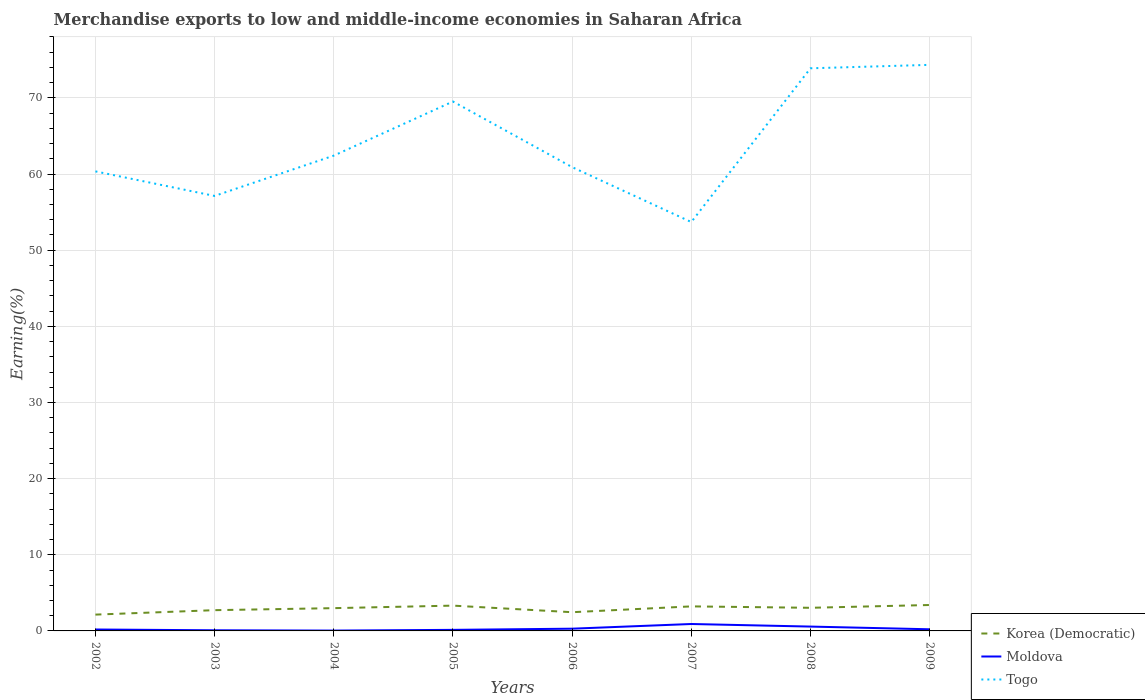Across all years, what is the maximum percentage of amount earned from merchandise exports in Moldova?
Keep it short and to the point. 0.05. In which year was the percentage of amount earned from merchandise exports in Moldova maximum?
Your response must be concise. 2004. What is the total percentage of amount earned from merchandise exports in Togo in the graph?
Offer a very short reply. -5.29. What is the difference between the highest and the second highest percentage of amount earned from merchandise exports in Togo?
Ensure brevity in your answer.  20.64. Is the percentage of amount earned from merchandise exports in Korea (Democratic) strictly greater than the percentage of amount earned from merchandise exports in Moldova over the years?
Provide a succinct answer. No. What is the difference between two consecutive major ticks on the Y-axis?
Make the answer very short. 10. Does the graph contain any zero values?
Keep it short and to the point. No. Does the graph contain grids?
Give a very brief answer. Yes. How many legend labels are there?
Your response must be concise. 3. How are the legend labels stacked?
Offer a very short reply. Vertical. What is the title of the graph?
Give a very brief answer. Merchandise exports to low and middle-income economies in Saharan Africa. Does "Benin" appear as one of the legend labels in the graph?
Make the answer very short. No. What is the label or title of the X-axis?
Provide a succinct answer. Years. What is the label or title of the Y-axis?
Offer a terse response. Earning(%). What is the Earning(%) of Korea (Democratic) in 2002?
Your answer should be compact. 2.14. What is the Earning(%) in Moldova in 2002?
Your answer should be compact. 0.19. What is the Earning(%) in Togo in 2002?
Offer a terse response. 60.35. What is the Earning(%) of Korea (Democratic) in 2003?
Offer a terse response. 2.73. What is the Earning(%) of Moldova in 2003?
Keep it short and to the point. 0.08. What is the Earning(%) of Togo in 2003?
Ensure brevity in your answer.  57.13. What is the Earning(%) in Korea (Democratic) in 2004?
Your answer should be very brief. 2.99. What is the Earning(%) of Moldova in 2004?
Give a very brief answer. 0.05. What is the Earning(%) in Togo in 2004?
Offer a very short reply. 62.42. What is the Earning(%) of Korea (Democratic) in 2005?
Give a very brief answer. 3.32. What is the Earning(%) in Moldova in 2005?
Make the answer very short. 0.14. What is the Earning(%) of Togo in 2005?
Give a very brief answer. 69.53. What is the Earning(%) in Korea (Democratic) in 2006?
Your answer should be very brief. 2.46. What is the Earning(%) of Moldova in 2006?
Give a very brief answer. 0.29. What is the Earning(%) in Togo in 2006?
Keep it short and to the point. 60.91. What is the Earning(%) of Korea (Democratic) in 2007?
Your response must be concise. 3.22. What is the Earning(%) in Moldova in 2007?
Your response must be concise. 0.91. What is the Earning(%) in Togo in 2007?
Your answer should be very brief. 53.7. What is the Earning(%) in Korea (Democratic) in 2008?
Provide a short and direct response. 3.04. What is the Earning(%) of Moldova in 2008?
Offer a terse response. 0.57. What is the Earning(%) of Togo in 2008?
Your answer should be compact. 73.89. What is the Earning(%) of Korea (Democratic) in 2009?
Offer a very short reply. 3.4. What is the Earning(%) of Moldova in 2009?
Offer a very short reply. 0.21. What is the Earning(%) of Togo in 2009?
Your answer should be compact. 74.34. Across all years, what is the maximum Earning(%) of Korea (Democratic)?
Your answer should be compact. 3.4. Across all years, what is the maximum Earning(%) in Moldova?
Provide a short and direct response. 0.91. Across all years, what is the maximum Earning(%) of Togo?
Offer a very short reply. 74.34. Across all years, what is the minimum Earning(%) of Korea (Democratic)?
Keep it short and to the point. 2.14. Across all years, what is the minimum Earning(%) of Moldova?
Give a very brief answer. 0.05. Across all years, what is the minimum Earning(%) of Togo?
Ensure brevity in your answer.  53.7. What is the total Earning(%) in Korea (Democratic) in the graph?
Your response must be concise. 23.3. What is the total Earning(%) of Moldova in the graph?
Provide a succinct answer. 2.44. What is the total Earning(%) in Togo in the graph?
Make the answer very short. 512.25. What is the difference between the Earning(%) of Korea (Democratic) in 2002 and that in 2003?
Make the answer very short. -0.58. What is the difference between the Earning(%) of Moldova in 2002 and that in 2003?
Ensure brevity in your answer.  0.1. What is the difference between the Earning(%) in Togo in 2002 and that in 2003?
Provide a succinct answer. 3.22. What is the difference between the Earning(%) of Korea (Democratic) in 2002 and that in 2004?
Keep it short and to the point. -0.85. What is the difference between the Earning(%) in Moldova in 2002 and that in 2004?
Your answer should be very brief. 0.14. What is the difference between the Earning(%) in Togo in 2002 and that in 2004?
Keep it short and to the point. -2.07. What is the difference between the Earning(%) in Korea (Democratic) in 2002 and that in 2005?
Your answer should be compact. -1.18. What is the difference between the Earning(%) of Moldova in 2002 and that in 2005?
Give a very brief answer. 0.05. What is the difference between the Earning(%) in Togo in 2002 and that in 2005?
Your response must be concise. -9.17. What is the difference between the Earning(%) in Korea (Democratic) in 2002 and that in 2006?
Your answer should be compact. -0.32. What is the difference between the Earning(%) of Moldova in 2002 and that in 2006?
Your answer should be very brief. -0.11. What is the difference between the Earning(%) of Togo in 2002 and that in 2006?
Ensure brevity in your answer.  -0.56. What is the difference between the Earning(%) of Korea (Democratic) in 2002 and that in 2007?
Keep it short and to the point. -1.08. What is the difference between the Earning(%) of Moldova in 2002 and that in 2007?
Offer a very short reply. -0.72. What is the difference between the Earning(%) in Togo in 2002 and that in 2007?
Your response must be concise. 6.65. What is the difference between the Earning(%) of Korea (Democratic) in 2002 and that in 2008?
Your response must be concise. -0.89. What is the difference between the Earning(%) in Moldova in 2002 and that in 2008?
Offer a terse response. -0.38. What is the difference between the Earning(%) in Togo in 2002 and that in 2008?
Provide a short and direct response. -13.54. What is the difference between the Earning(%) in Korea (Democratic) in 2002 and that in 2009?
Offer a very short reply. -1.26. What is the difference between the Earning(%) in Moldova in 2002 and that in 2009?
Provide a short and direct response. -0.03. What is the difference between the Earning(%) of Togo in 2002 and that in 2009?
Your answer should be compact. -13.99. What is the difference between the Earning(%) of Korea (Democratic) in 2003 and that in 2004?
Offer a very short reply. -0.27. What is the difference between the Earning(%) of Moldova in 2003 and that in 2004?
Offer a terse response. 0.04. What is the difference between the Earning(%) of Togo in 2003 and that in 2004?
Give a very brief answer. -5.29. What is the difference between the Earning(%) in Korea (Democratic) in 2003 and that in 2005?
Provide a short and direct response. -0.6. What is the difference between the Earning(%) in Moldova in 2003 and that in 2005?
Provide a succinct answer. -0.05. What is the difference between the Earning(%) of Togo in 2003 and that in 2005?
Give a very brief answer. -12.4. What is the difference between the Earning(%) of Korea (Democratic) in 2003 and that in 2006?
Keep it short and to the point. 0.27. What is the difference between the Earning(%) of Moldova in 2003 and that in 2006?
Provide a succinct answer. -0.21. What is the difference between the Earning(%) in Togo in 2003 and that in 2006?
Provide a short and direct response. -3.78. What is the difference between the Earning(%) in Korea (Democratic) in 2003 and that in 2007?
Provide a short and direct response. -0.5. What is the difference between the Earning(%) in Moldova in 2003 and that in 2007?
Make the answer very short. -0.82. What is the difference between the Earning(%) of Togo in 2003 and that in 2007?
Your response must be concise. 3.43. What is the difference between the Earning(%) of Korea (Democratic) in 2003 and that in 2008?
Offer a terse response. -0.31. What is the difference between the Earning(%) in Moldova in 2003 and that in 2008?
Provide a short and direct response. -0.49. What is the difference between the Earning(%) of Togo in 2003 and that in 2008?
Provide a short and direct response. -16.76. What is the difference between the Earning(%) in Korea (Democratic) in 2003 and that in 2009?
Your response must be concise. -0.68. What is the difference between the Earning(%) of Moldova in 2003 and that in 2009?
Make the answer very short. -0.13. What is the difference between the Earning(%) of Togo in 2003 and that in 2009?
Your response must be concise. -17.21. What is the difference between the Earning(%) in Korea (Democratic) in 2004 and that in 2005?
Offer a very short reply. -0.33. What is the difference between the Earning(%) in Moldova in 2004 and that in 2005?
Your answer should be very brief. -0.09. What is the difference between the Earning(%) in Togo in 2004 and that in 2005?
Keep it short and to the point. -7.11. What is the difference between the Earning(%) in Korea (Democratic) in 2004 and that in 2006?
Your answer should be compact. 0.53. What is the difference between the Earning(%) in Moldova in 2004 and that in 2006?
Offer a terse response. -0.25. What is the difference between the Earning(%) of Togo in 2004 and that in 2006?
Offer a very short reply. 1.51. What is the difference between the Earning(%) in Korea (Democratic) in 2004 and that in 2007?
Keep it short and to the point. -0.23. What is the difference between the Earning(%) of Moldova in 2004 and that in 2007?
Make the answer very short. -0.86. What is the difference between the Earning(%) in Togo in 2004 and that in 2007?
Offer a terse response. 8.72. What is the difference between the Earning(%) in Korea (Democratic) in 2004 and that in 2008?
Offer a very short reply. -0.05. What is the difference between the Earning(%) of Moldova in 2004 and that in 2008?
Your response must be concise. -0.52. What is the difference between the Earning(%) of Togo in 2004 and that in 2008?
Offer a very short reply. -11.47. What is the difference between the Earning(%) in Korea (Democratic) in 2004 and that in 2009?
Offer a very short reply. -0.41. What is the difference between the Earning(%) of Moldova in 2004 and that in 2009?
Keep it short and to the point. -0.17. What is the difference between the Earning(%) of Togo in 2004 and that in 2009?
Your answer should be compact. -11.92. What is the difference between the Earning(%) of Korea (Democratic) in 2005 and that in 2006?
Provide a short and direct response. 0.86. What is the difference between the Earning(%) of Moldova in 2005 and that in 2006?
Keep it short and to the point. -0.15. What is the difference between the Earning(%) in Togo in 2005 and that in 2006?
Give a very brief answer. 8.62. What is the difference between the Earning(%) in Korea (Democratic) in 2005 and that in 2007?
Offer a very short reply. 0.1. What is the difference between the Earning(%) of Moldova in 2005 and that in 2007?
Offer a very short reply. -0.77. What is the difference between the Earning(%) in Togo in 2005 and that in 2007?
Provide a succinct answer. 15.83. What is the difference between the Earning(%) of Korea (Democratic) in 2005 and that in 2008?
Offer a terse response. 0.28. What is the difference between the Earning(%) in Moldova in 2005 and that in 2008?
Your answer should be compact. -0.43. What is the difference between the Earning(%) of Togo in 2005 and that in 2008?
Your answer should be compact. -4.36. What is the difference between the Earning(%) of Korea (Democratic) in 2005 and that in 2009?
Offer a very short reply. -0.08. What is the difference between the Earning(%) of Moldova in 2005 and that in 2009?
Your response must be concise. -0.08. What is the difference between the Earning(%) of Togo in 2005 and that in 2009?
Give a very brief answer. -4.81. What is the difference between the Earning(%) of Korea (Democratic) in 2006 and that in 2007?
Your answer should be very brief. -0.76. What is the difference between the Earning(%) in Moldova in 2006 and that in 2007?
Provide a succinct answer. -0.62. What is the difference between the Earning(%) in Togo in 2006 and that in 2007?
Offer a terse response. 7.21. What is the difference between the Earning(%) of Korea (Democratic) in 2006 and that in 2008?
Your response must be concise. -0.58. What is the difference between the Earning(%) of Moldova in 2006 and that in 2008?
Your answer should be very brief. -0.28. What is the difference between the Earning(%) in Togo in 2006 and that in 2008?
Your answer should be compact. -12.98. What is the difference between the Earning(%) in Korea (Democratic) in 2006 and that in 2009?
Ensure brevity in your answer.  -0.95. What is the difference between the Earning(%) of Moldova in 2006 and that in 2009?
Ensure brevity in your answer.  0.08. What is the difference between the Earning(%) in Togo in 2006 and that in 2009?
Ensure brevity in your answer.  -13.43. What is the difference between the Earning(%) of Korea (Democratic) in 2007 and that in 2008?
Make the answer very short. 0.19. What is the difference between the Earning(%) of Moldova in 2007 and that in 2008?
Your answer should be compact. 0.34. What is the difference between the Earning(%) in Togo in 2007 and that in 2008?
Provide a succinct answer. -20.19. What is the difference between the Earning(%) of Korea (Democratic) in 2007 and that in 2009?
Give a very brief answer. -0.18. What is the difference between the Earning(%) of Moldova in 2007 and that in 2009?
Your response must be concise. 0.69. What is the difference between the Earning(%) in Togo in 2007 and that in 2009?
Your response must be concise. -20.64. What is the difference between the Earning(%) of Korea (Democratic) in 2008 and that in 2009?
Make the answer very short. -0.37. What is the difference between the Earning(%) in Moldova in 2008 and that in 2009?
Offer a very short reply. 0.36. What is the difference between the Earning(%) of Togo in 2008 and that in 2009?
Ensure brevity in your answer.  -0.45. What is the difference between the Earning(%) of Korea (Democratic) in 2002 and the Earning(%) of Moldova in 2003?
Ensure brevity in your answer.  2.06. What is the difference between the Earning(%) in Korea (Democratic) in 2002 and the Earning(%) in Togo in 2003?
Your response must be concise. -54.98. What is the difference between the Earning(%) in Moldova in 2002 and the Earning(%) in Togo in 2003?
Offer a very short reply. -56.94. What is the difference between the Earning(%) of Korea (Democratic) in 2002 and the Earning(%) of Moldova in 2004?
Make the answer very short. 2.1. What is the difference between the Earning(%) of Korea (Democratic) in 2002 and the Earning(%) of Togo in 2004?
Provide a short and direct response. -60.28. What is the difference between the Earning(%) in Moldova in 2002 and the Earning(%) in Togo in 2004?
Ensure brevity in your answer.  -62.23. What is the difference between the Earning(%) of Korea (Democratic) in 2002 and the Earning(%) of Moldova in 2005?
Your answer should be compact. 2. What is the difference between the Earning(%) of Korea (Democratic) in 2002 and the Earning(%) of Togo in 2005?
Provide a short and direct response. -67.38. What is the difference between the Earning(%) of Moldova in 2002 and the Earning(%) of Togo in 2005?
Offer a terse response. -69.34. What is the difference between the Earning(%) of Korea (Democratic) in 2002 and the Earning(%) of Moldova in 2006?
Your answer should be very brief. 1.85. What is the difference between the Earning(%) of Korea (Democratic) in 2002 and the Earning(%) of Togo in 2006?
Offer a terse response. -58.77. What is the difference between the Earning(%) in Moldova in 2002 and the Earning(%) in Togo in 2006?
Offer a terse response. -60.72. What is the difference between the Earning(%) of Korea (Democratic) in 2002 and the Earning(%) of Moldova in 2007?
Your answer should be compact. 1.23. What is the difference between the Earning(%) of Korea (Democratic) in 2002 and the Earning(%) of Togo in 2007?
Provide a short and direct response. -51.55. What is the difference between the Earning(%) of Moldova in 2002 and the Earning(%) of Togo in 2007?
Provide a short and direct response. -53.51. What is the difference between the Earning(%) of Korea (Democratic) in 2002 and the Earning(%) of Moldova in 2008?
Your response must be concise. 1.57. What is the difference between the Earning(%) in Korea (Democratic) in 2002 and the Earning(%) in Togo in 2008?
Offer a very short reply. -71.75. What is the difference between the Earning(%) of Moldova in 2002 and the Earning(%) of Togo in 2008?
Make the answer very short. -73.7. What is the difference between the Earning(%) of Korea (Democratic) in 2002 and the Earning(%) of Moldova in 2009?
Keep it short and to the point. 1.93. What is the difference between the Earning(%) in Korea (Democratic) in 2002 and the Earning(%) in Togo in 2009?
Provide a short and direct response. -72.2. What is the difference between the Earning(%) of Moldova in 2002 and the Earning(%) of Togo in 2009?
Provide a short and direct response. -74.15. What is the difference between the Earning(%) in Korea (Democratic) in 2003 and the Earning(%) in Moldova in 2004?
Your answer should be very brief. 2.68. What is the difference between the Earning(%) of Korea (Democratic) in 2003 and the Earning(%) of Togo in 2004?
Your answer should be very brief. -59.69. What is the difference between the Earning(%) in Moldova in 2003 and the Earning(%) in Togo in 2004?
Your answer should be very brief. -62.33. What is the difference between the Earning(%) in Korea (Democratic) in 2003 and the Earning(%) in Moldova in 2005?
Make the answer very short. 2.59. What is the difference between the Earning(%) of Korea (Democratic) in 2003 and the Earning(%) of Togo in 2005?
Provide a succinct answer. -66.8. What is the difference between the Earning(%) of Moldova in 2003 and the Earning(%) of Togo in 2005?
Provide a succinct answer. -69.44. What is the difference between the Earning(%) in Korea (Democratic) in 2003 and the Earning(%) in Moldova in 2006?
Your answer should be compact. 2.43. What is the difference between the Earning(%) in Korea (Democratic) in 2003 and the Earning(%) in Togo in 2006?
Give a very brief answer. -58.18. What is the difference between the Earning(%) of Moldova in 2003 and the Earning(%) of Togo in 2006?
Keep it short and to the point. -60.82. What is the difference between the Earning(%) in Korea (Democratic) in 2003 and the Earning(%) in Moldova in 2007?
Your response must be concise. 1.82. What is the difference between the Earning(%) in Korea (Democratic) in 2003 and the Earning(%) in Togo in 2007?
Your response must be concise. -50.97. What is the difference between the Earning(%) of Moldova in 2003 and the Earning(%) of Togo in 2007?
Your response must be concise. -53.61. What is the difference between the Earning(%) of Korea (Democratic) in 2003 and the Earning(%) of Moldova in 2008?
Your answer should be compact. 2.16. What is the difference between the Earning(%) in Korea (Democratic) in 2003 and the Earning(%) in Togo in 2008?
Make the answer very short. -71.16. What is the difference between the Earning(%) of Moldova in 2003 and the Earning(%) of Togo in 2008?
Ensure brevity in your answer.  -73.8. What is the difference between the Earning(%) in Korea (Democratic) in 2003 and the Earning(%) in Moldova in 2009?
Your response must be concise. 2.51. What is the difference between the Earning(%) of Korea (Democratic) in 2003 and the Earning(%) of Togo in 2009?
Offer a very short reply. -71.61. What is the difference between the Earning(%) of Moldova in 2003 and the Earning(%) of Togo in 2009?
Provide a short and direct response. -74.25. What is the difference between the Earning(%) in Korea (Democratic) in 2004 and the Earning(%) in Moldova in 2005?
Your response must be concise. 2.85. What is the difference between the Earning(%) of Korea (Democratic) in 2004 and the Earning(%) of Togo in 2005?
Give a very brief answer. -66.53. What is the difference between the Earning(%) of Moldova in 2004 and the Earning(%) of Togo in 2005?
Offer a terse response. -69.48. What is the difference between the Earning(%) of Korea (Democratic) in 2004 and the Earning(%) of Moldova in 2006?
Your response must be concise. 2.7. What is the difference between the Earning(%) of Korea (Democratic) in 2004 and the Earning(%) of Togo in 2006?
Provide a succinct answer. -57.92. What is the difference between the Earning(%) in Moldova in 2004 and the Earning(%) in Togo in 2006?
Offer a very short reply. -60.86. What is the difference between the Earning(%) in Korea (Democratic) in 2004 and the Earning(%) in Moldova in 2007?
Your answer should be compact. 2.08. What is the difference between the Earning(%) of Korea (Democratic) in 2004 and the Earning(%) of Togo in 2007?
Your response must be concise. -50.71. What is the difference between the Earning(%) of Moldova in 2004 and the Earning(%) of Togo in 2007?
Offer a terse response. -53.65. What is the difference between the Earning(%) of Korea (Democratic) in 2004 and the Earning(%) of Moldova in 2008?
Your response must be concise. 2.42. What is the difference between the Earning(%) of Korea (Democratic) in 2004 and the Earning(%) of Togo in 2008?
Your response must be concise. -70.9. What is the difference between the Earning(%) in Moldova in 2004 and the Earning(%) in Togo in 2008?
Keep it short and to the point. -73.84. What is the difference between the Earning(%) of Korea (Democratic) in 2004 and the Earning(%) of Moldova in 2009?
Your answer should be very brief. 2.78. What is the difference between the Earning(%) in Korea (Democratic) in 2004 and the Earning(%) in Togo in 2009?
Ensure brevity in your answer.  -71.35. What is the difference between the Earning(%) of Moldova in 2004 and the Earning(%) of Togo in 2009?
Give a very brief answer. -74.29. What is the difference between the Earning(%) in Korea (Democratic) in 2005 and the Earning(%) in Moldova in 2006?
Your answer should be compact. 3.03. What is the difference between the Earning(%) of Korea (Democratic) in 2005 and the Earning(%) of Togo in 2006?
Provide a short and direct response. -57.59. What is the difference between the Earning(%) in Moldova in 2005 and the Earning(%) in Togo in 2006?
Offer a terse response. -60.77. What is the difference between the Earning(%) in Korea (Democratic) in 2005 and the Earning(%) in Moldova in 2007?
Offer a very short reply. 2.41. What is the difference between the Earning(%) of Korea (Democratic) in 2005 and the Earning(%) of Togo in 2007?
Keep it short and to the point. -50.38. What is the difference between the Earning(%) of Moldova in 2005 and the Earning(%) of Togo in 2007?
Make the answer very short. -53.56. What is the difference between the Earning(%) of Korea (Democratic) in 2005 and the Earning(%) of Moldova in 2008?
Offer a very short reply. 2.75. What is the difference between the Earning(%) in Korea (Democratic) in 2005 and the Earning(%) in Togo in 2008?
Provide a succinct answer. -70.57. What is the difference between the Earning(%) of Moldova in 2005 and the Earning(%) of Togo in 2008?
Offer a very short reply. -73.75. What is the difference between the Earning(%) in Korea (Democratic) in 2005 and the Earning(%) in Moldova in 2009?
Offer a very short reply. 3.11. What is the difference between the Earning(%) in Korea (Democratic) in 2005 and the Earning(%) in Togo in 2009?
Your answer should be very brief. -71.02. What is the difference between the Earning(%) in Moldova in 2005 and the Earning(%) in Togo in 2009?
Your answer should be very brief. -74.2. What is the difference between the Earning(%) of Korea (Democratic) in 2006 and the Earning(%) of Moldova in 2007?
Make the answer very short. 1.55. What is the difference between the Earning(%) of Korea (Democratic) in 2006 and the Earning(%) of Togo in 2007?
Make the answer very short. -51.24. What is the difference between the Earning(%) in Moldova in 2006 and the Earning(%) in Togo in 2007?
Ensure brevity in your answer.  -53.4. What is the difference between the Earning(%) of Korea (Democratic) in 2006 and the Earning(%) of Moldova in 2008?
Offer a very short reply. 1.89. What is the difference between the Earning(%) in Korea (Democratic) in 2006 and the Earning(%) in Togo in 2008?
Provide a succinct answer. -71.43. What is the difference between the Earning(%) in Moldova in 2006 and the Earning(%) in Togo in 2008?
Provide a succinct answer. -73.6. What is the difference between the Earning(%) of Korea (Democratic) in 2006 and the Earning(%) of Moldova in 2009?
Your answer should be compact. 2.24. What is the difference between the Earning(%) of Korea (Democratic) in 2006 and the Earning(%) of Togo in 2009?
Provide a succinct answer. -71.88. What is the difference between the Earning(%) in Moldova in 2006 and the Earning(%) in Togo in 2009?
Offer a terse response. -74.05. What is the difference between the Earning(%) in Korea (Democratic) in 2007 and the Earning(%) in Moldova in 2008?
Keep it short and to the point. 2.65. What is the difference between the Earning(%) of Korea (Democratic) in 2007 and the Earning(%) of Togo in 2008?
Offer a very short reply. -70.67. What is the difference between the Earning(%) of Moldova in 2007 and the Earning(%) of Togo in 2008?
Make the answer very short. -72.98. What is the difference between the Earning(%) in Korea (Democratic) in 2007 and the Earning(%) in Moldova in 2009?
Keep it short and to the point. 3.01. What is the difference between the Earning(%) in Korea (Democratic) in 2007 and the Earning(%) in Togo in 2009?
Ensure brevity in your answer.  -71.12. What is the difference between the Earning(%) of Moldova in 2007 and the Earning(%) of Togo in 2009?
Ensure brevity in your answer.  -73.43. What is the difference between the Earning(%) of Korea (Democratic) in 2008 and the Earning(%) of Moldova in 2009?
Your response must be concise. 2.82. What is the difference between the Earning(%) of Korea (Democratic) in 2008 and the Earning(%) of Togo in 2009?
Offer a terse response. -71.3. What is the difference between the Earning(%) of Moldova in 2008 and the Earning(%) of Togo in 2009?
Keep it short and to the point. -73.77. What is the average Earning(%) in Korea (Democratic) per year?
Make the answer very short. 2.91. What is the average Earning(%) of Moldova per year?
Provide a short and direct response. 0.31. What is the average Earning(%) of Togo per year?
Your response must be concise. 64.03. In the year 2002, what is the difference between the Earning(%) of Korea (Democratic) and Earning(%) of Moldova?
Give a very brief answer. 1.96. In the year 2002, what is the difference between the Earning(%) in Korea (Democratic) and Earning(%) in Togo?
Keep it short and to the point. -58.21. In the year 2002, what is the difference between the Earning(%) of Moldova and Earning(%) of Togo?
Your answer should be compact. -60.17. In the year 2003, what is the difference between the Earning(%) of Korea (Democratic) and Earning(%) of Moldova?
Give a very brief answer. 2.64. In the year 2003, what is the difference between the Earning(%) of Korea (Democratic) and Earning(%) of Togo?
Your answer should be very brief. -54.4. In the year 2003, what is the difference between the Earning(%) in Moldova and Earning(%) in Togo?
Offer a very short reply. -57.04. In the year 2004, what is the difference between the Earning(%) of Korea (Democratic) and Earning(%) of Moldova?
Make the answer very short. 2.95. In the year 2004, what is the difference between the Earning(%) in Korea (Democratic) and Earning(%) in Togo?
Offer a terse response. -59.43. In the year 2004, what is the difference between the Earning(%) of Moldova and Earning(%) of Togo?
Your response must be concise. -62.37. In the year 2005, what is the difference between the Earning(%) of Korea (Democratic) and Earning(%) of Moldova?
Make the answer very short. 3.18. In the year 2005, what is the difference between the Earning(%) in Korea (Democratic) and Earning(%) in Togo?
Your answer should be compact. -66.2. In the year 2005, what is the difference between the Earning(%) of Moldova and Earning(%) of Togo?
Your answer should be compact. -69.39. In the year 2006, what is the difference between the Earning(%) in Korea (Democratic) and Earning(%) in Moldova?
Ensure brevity in your answer.  2.16. In the year 2006, what is the difference between the Earning(%) in Korea (Democratic) and Earning(%) in Togo?
Offer a very short reply. -58.45. In the year 2006, what is the difference between the Earning(%) in Moldova and Earning(%) in Togo?
Provide a short and direct response. -60.62. In the year 2007, what is the difference between the Earning(%) of Korea (Democratic) and Earning(%) of Moldova?
Provide a succinct answer. 2.31. In the year 2007, what is the difference between the Earning(%) of Korea (Democratic) and Earning(%) of Togo?
Ensure brevity in your answer.  -50.47. In the year 2007, what is the difference between the Earning(%) of Moldova and Earning(%) of Togo?
Provide a succinct answer. -52.79. In the year 2008, what is the difference between the Earning(%) in Korea (Democratic) and Earning(%) in Moldova?
Give a very brief answer. 2.47. In the year 2008, what is the difference between the Earning(%) in Korea (Democratic) and Earning(%) in Togo?
Keep it short and to the point. -70.85. In the year 2008, what is the difference between the Earning(%) in Moldova and Earning(%) in Togo?
Your answer should be compact. -73.32. In the year 2009, what is the difference between the Earning(%) in Korea (Democratic) and Earning(%) in Moldova?
Provide a succinct answer. 3.19. In the year 2009, what is the difference between the Earning(%) in Korea (Democratic) and Earning(%) in Togo?
Offer a very short reply. -70.93. In the year 2009, what is the difference between the Earning(%) of Moldova and Earning(%) of Togo?
Your answer should be compact. -74.12. What is the ratio of the Earning(%) in Korea (Democratic) in 2002 to that in 2003?
Offer a very short reply. 0.79. What is the ratio of the Earning(%) of Moldova in 2002 to that in 2003?
Provide a succinct answer. 2.2. What is the ratio of the Earning(%) of Togo in 2002 to that in 2003?
Ensure brevity in your answer.  1.06. What is the ratio of the Earning(%) of Korea (Democratic) in 2002 to that in 2004?
Your answer should be very brief. 0.72. What is the ratio of the Earning(%) in Moldova in 2002 to that in 2004?
Your response must be concise. 4.03. What is the ratio of the Earning(%) of Togo in 2002 to that in 2004?
Provide a short and direct response. 0.97. What is the ratio of the Earning(%) of Korea (Democratic) in 2002 to that in 2005?
Offer a terse response. 0.65. What is the ratio of the Earning(%) of Moldova in 2002 to that in 2005?
Give a very brief answer. 1.34. What is the ratio of the Earning(%) in Togo in 2002 to that in 2005?
Make the answer very short. 0.87. What is the ratio of the Earning(%) of Korea (Democratic) in 2002 to that in 2006?
Make the answer very short. 0.87. What is the ratio of the Earning(%) in Moldova in 2002 to that in 2006?
Offer a very short reply. 0.63. What is the ratio of the Earning(%) of Korea (Democratic) in 2002 to that in 2007?
Make the answer very short. 0.66. What is the ratio of the Earning(%) of Moldova in 2002 to that in 2007?
Make the answer very short. 0.2. What is the ratio of the Earning(%) in Togo in 2002 to that in 2007?
Offer a very short reply. 1.12. What is the ratio of the Earning(%) in Korea (Democratic) in 2002 to that in 2008?
Give a very brief answer. 0.71. What is the ratio of the Earning(%) in Moldova in 2002 to that in 2008?
Provide a succinct answer. 0.33. What is the ratio of the Earning(%) of Togo in 2002 to that in 2008?
Ensure brevity in your answer.  0.82. What is the ratio of the Earning(%) in Korea (Democratic) in 2002 to that in 2009?
Keep it short and to the point. 0.63. What is the ratio of the Earning(%) of Moldova in 2002 to that in 2009?
Your answer should be very brief. 0.87. What is the ratio of the Earning(%) of Togo in 2002 to that in 2009?
Keep it short and to the point. 0.81. What is the ratio of the Earning(%) in Korea (Democratic) in 2003 to that in 2004?
Your response must be concise. 0.91. What is the ratio of the Earning(%) in Moldova in 2003 to that in 2004?
Your answer should be very brief. 1.83. What is the ratio of the Earning(%) in Togo in 2003 to that in 2004?
Give a very brief answer. 0.92. What is the ratio of the Earning(%) of Korea (Democratic) in 2003 to that in 2005?
Ensure brevity in your answer.  0.82. What is the ratio of the Earning(%) of Moldova in 2003 to that in 2005?
Give a very brief answer. 0.61. What is the ratio of the Earning(%) in Togo in 2003 to that in 2005?
Your answer should be compact. 0.82. What is the ratio of the Earning(%) of Korea (Democratic) in 2003 to that in 2006?
Offer a very short reply. 1.11. What is the ratio of the Earning(%) in Moldova in 2003 to that in 2006?
Keep it short and to the point. 0.29. What is the ratio of the Earning(%) of Togo in 2003 to that in 2006?
Keep it short and to the point. 0.94. What is the ratio of the Earning(%) of Korea (Democratic) in 2003 to that in 2007?
Offer a very short reply. 0.85. What is the ratio of the Earning(%) of Moldova in 2003 to that in 2007?
Your response must be concise. 0.09. What is the ratio of the Earning(%) of Togo in 2003 to that in 2007?
Your answer should be very brief. 1.06. What is the ratio of the Earning(%) of Korea (Democratic) in 2003 to that in 2008?
Offer a terse response. 0.9. What is the ratio of the Earning(%) of Moldova in 2003 to that in 2008?
Provide a succinct answer. 0.15. What is the ratio of the Earning(%) in Togo in 2003 to that in 2008?
Provide a short and direct response. 0.77. What is the ratio of the Earning(%) in Korea (Democratic) in 2003 to that in 2009?
Offer a very short reply. 0.8. What is the ratio of the Earning(%) of Moldova in 2003 to that in 2009?
Your answer should be very brief. 0.39. What is the ratio of the Earning(%) of Togo in 2003 to that in 2009?
Make the answer very short. 0.77. What is the ratio of the Earning(%) of Korea (Democratic) in 2004 to that in 2005?
Keep it short and to the point. 0.9. What is the ratio of the Earning(%) of Moldova in 2004 to that in 2005?
Keep it short and to the point. 0.33. What is the ratio of the Earning(%) of Togo in 2004 to that in 2005?
Keep it short and to the point. 0.9. What is the ratio of the Earning(%) of Korea (Democratic) in 2004 to that in 2006?
Your answer should be compact. 1.22. What is the ratio of the Earning(%) of Moldova in 2004 to that in 2006?
Keep it short and to the point. 0.16. What is the ratio of the Earning(%) in Togo in 2004 to that in 2006?
Your answer should be compact. 1.02. What is the ratio of the Earning(%) in Korea (Democratic) in 2004 to that in 2007?
Your answer should be very brief. 0.93. What is the ratio of the Earning(%) of Moldova in 2004 to that in 2007?
Make the answer very short. 0.05. What is the ratio of the Earning(%) in Togo in 2004 to that in 2007?
Provide a short and direct response. 1.16. What is the ratio of the Earning(%) of Moldova in 2004 to that in 2008?
Provide a short and direct response. 0.08. What is the ratio of the Earning(%) in Togo in 2004 to that in 2008?
Provide a succinct answer. 0.84. What is the ratio of the Earning(%) in Korea (Democratic) in 2004 to that in 2009?
Provide a short and direct response. 0.88. What is the ratio of the Earning(%) in Moldova in 2004 to that in 2009?
Give a very brief answer. 0.21. What is the ratio of the Earning(%) in Togo in 2004 to that in 2009?
Offer a very short reply. 0.84. What is the ratio of the Earning(%) in Korea (Democratic) in 2005 to that in 2006?
Offer a terse response. 1.35. What is the ratio of the Earning(%) in Moldova in 2005 to that in 2006?
Offer a terse response. 0.47. What is the ratio of the Earning(%) in Togo in 2005 to that in 2006?
Offer a terse response. 1.14. What is the ratio of the Earning(%) of Korea (Democratic) in 2005 to that in 2007?
Give a very brief answer. 1.03. What is the ratio of the Earning(%) of Moldova in 2005 to that in 2007?
Give a very brief answer. 0.15. What is the ratio of the Earning(%) of Togo in 2005 to that in 2007?
Give a very brief answer. 1.29. What is the ratio of the Earning(%) of Korea (Democratic) in 2005 to that in 2008?
Provide a short and direct response. 1.09. What is the ratio of the Earning(%) in Moldova in 2005 to that in 2008?
Offer a terse response. 0.24. What is the ratio of the Earning(%) of Togo in 2005 to that in 2008?
Provide a succinct answer. 0.94. What is the ratio of the Earning(%) of Korea (Democratic) in 2005 to that in 2009?
Offer a terse response. 0.98. What is the ratio of the Earning(%) in Moldova in 2005 to that in 2009?
Make the answer very short. 0.65. What is the ratio of the Earning(%) of Togo in 2005 to that in 2009?
Make the answer very short. 0.94. What is the ratio of the Earning(%) in Korea (Democratic) in 2006 to that in 2007?
Make the answer very short. 0.76. What is the ratio of the Earning(%) in Moldova in 2006 to that in 2007?
Provide a succinct answer. 0.32. What is the ratio of the Earning(%) in Togo in 2006 to that in 2007?
Your answer should be compact. 1.13. What is the ratio of the Earning(%) in Korea (Democratic) in 2006 to that in 2008?
Provide a short and direct response. 0.81. What is the ratio of the Earning(%) of Moldova in 2006 to that in 2008?
Your answer should be compact. 0.51. What is the ratio of the Earning(%) of Togo in 2006 to that in 2008?
Ensure brevity in your answer.  0.82. What is the ratio of the Earning(%) in Korea (Democratic) in 2006 to that in 2009?
Provide a short and direct response. 0.72. What is the ratio of the Earning(%) of Moldova in 2006 to that in 2009?
Provide a short and direct response. 1.37. What is the ratio of the Earning(%) in Togo in 2006 to that in 2009?
Keep it short and to the point. 0.82. What is the ratio of the Earning(%) of Korea (Democratic) in 2007 to that in 2008?
Your response must be concise. 1.06. What is the ratio of the Earning(%) in Moldova in 2007 to that in 2008?
Offer a very short reply. 1.6. What is the ratio of the Earning(%) in Togo in 2007 to that in 2008?
Make the answer very short. 0.73. What is the ratio of the Earning(%) in Korea (Democratic) in 2007 to that in 2009?
Your response must be concise. 0.95. What is the ratio of the Earning(%) of Moldova in 2007 to that in 2009?
Make the answer very short. 4.24. What is the ratio of the Earning(%) in Togo in 2007 to that in 2009?
Offer a terse response. 0.72. What is the ratio of the Earning(%) in Korea (Democratic) in 2008 to that in 2009?
Keep it short and to the point. 0.89. What is the ratio of the Earning(%) in Moldova in 2008 to that in 2009?
Keep it short and to the point. 2.66. What is the difference between the highest and the second highest Earning(%) of Korea (Democratic)?
Your response must be concise. 0.08. What is the difference between the highest and the second highest Earning(%) in Moldova?
Provide a short and direct response. 0.34. What is the difference between the highest and the second highest Earning(%) in Togo?
Provide a short and direct response. 0.45. What is the difference between the highest and the lowest Earning(%) in Korea (Democratic)?
Ensure brevity in your answer.  1.26. What is the difference between the highest and the lowest Earning(%) in Moldova?
Make the answer very short. 0.86. What is the difference between the highest and the lowest Earning(%) of Togo?
Offer a very short reply. 20.64. 